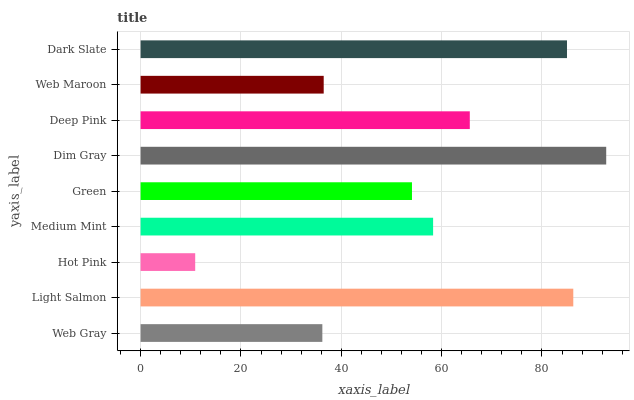Is Hot Pink the minimum?
Answer yes or no. Yes. Is Dim Gray the maximum?
Answer yes or no. Yes. Is Light Salmon the minimum?
Answer yes or no. No. Is Light Salmon the maximum?
Answer yes or no. No. Is Light Salmon greater than Web Gray?
Answer yes or no. Yes. Is Web Gray less than Light Salmon?
Answer yes or no. Yes. Is Web Gray greater than Light Salmon?
Answer yes or no. No. Is Light Salmon less than Web Gray?
Answer yes or no. No. Is Medium Mint the high median?
Answer yes or no. Yes. Is Medium Mint the low median?
Answer yes or no. Yes. Is Green the high median?
Answer yes or no. No. Is Deep Pink the low median?
Answer yes or no. No. 